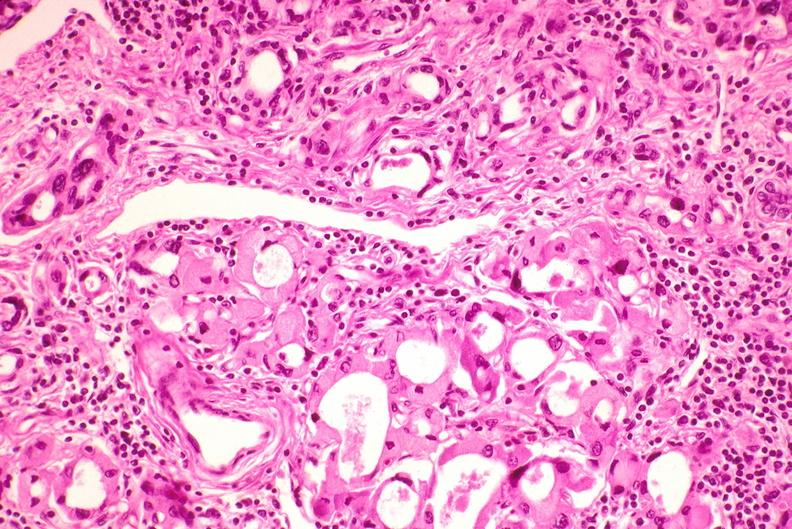where is this part in the figure?
Answer the question using a single word or phrase. Endocrine system 